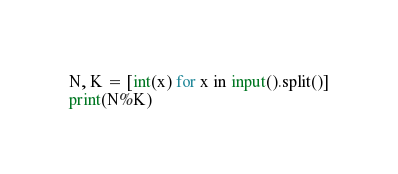Convert code to text. <code><loc_0><loc_0><loc_500><loc_500><_Python_>N, K = [int(x) for x in input().split()]
print(N%K)
</code> 